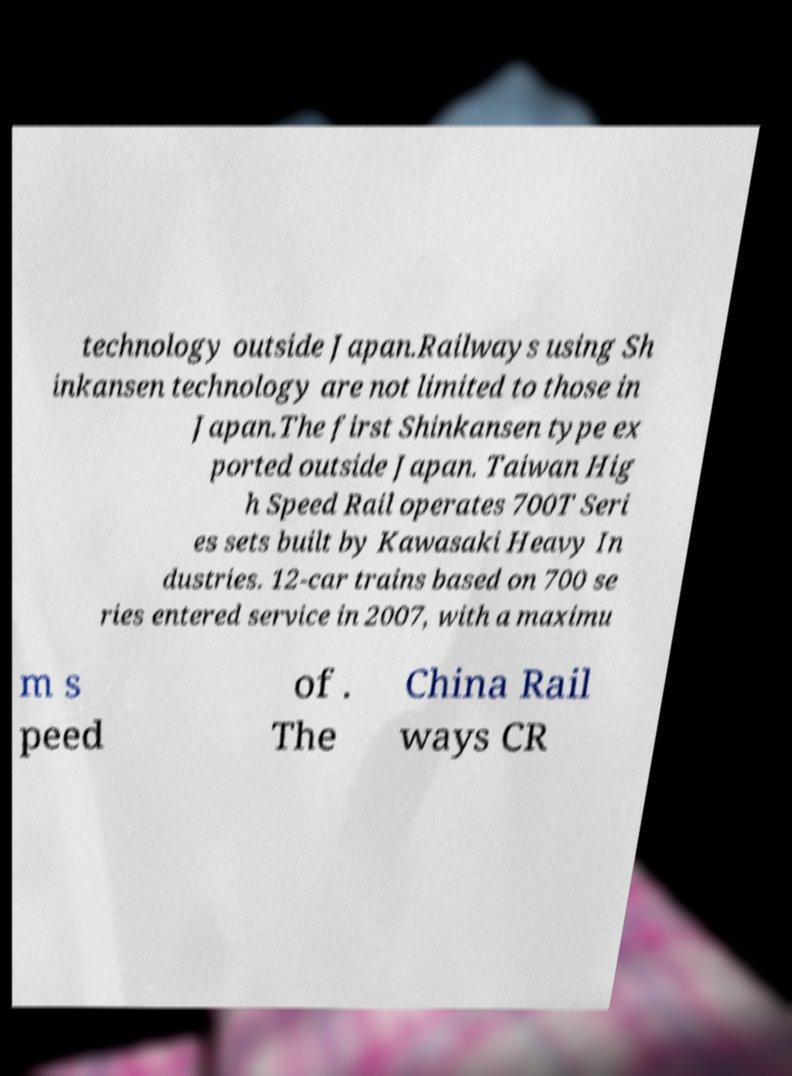Please read and relay the text visible in this image. What does it say? technology outside Japan.Railways using Sh inkansen technology are not limited to those in Japan.The first Shinkansen type ex ported outside Japan. Taiwan Hig h Speed Rail operates 700T Seri es sets built by Kawasaki Heavy In dustries. 12-car trains based on 700 se ries entered service in 2007, with a maximu m s peed of . The China Rail ways CR 